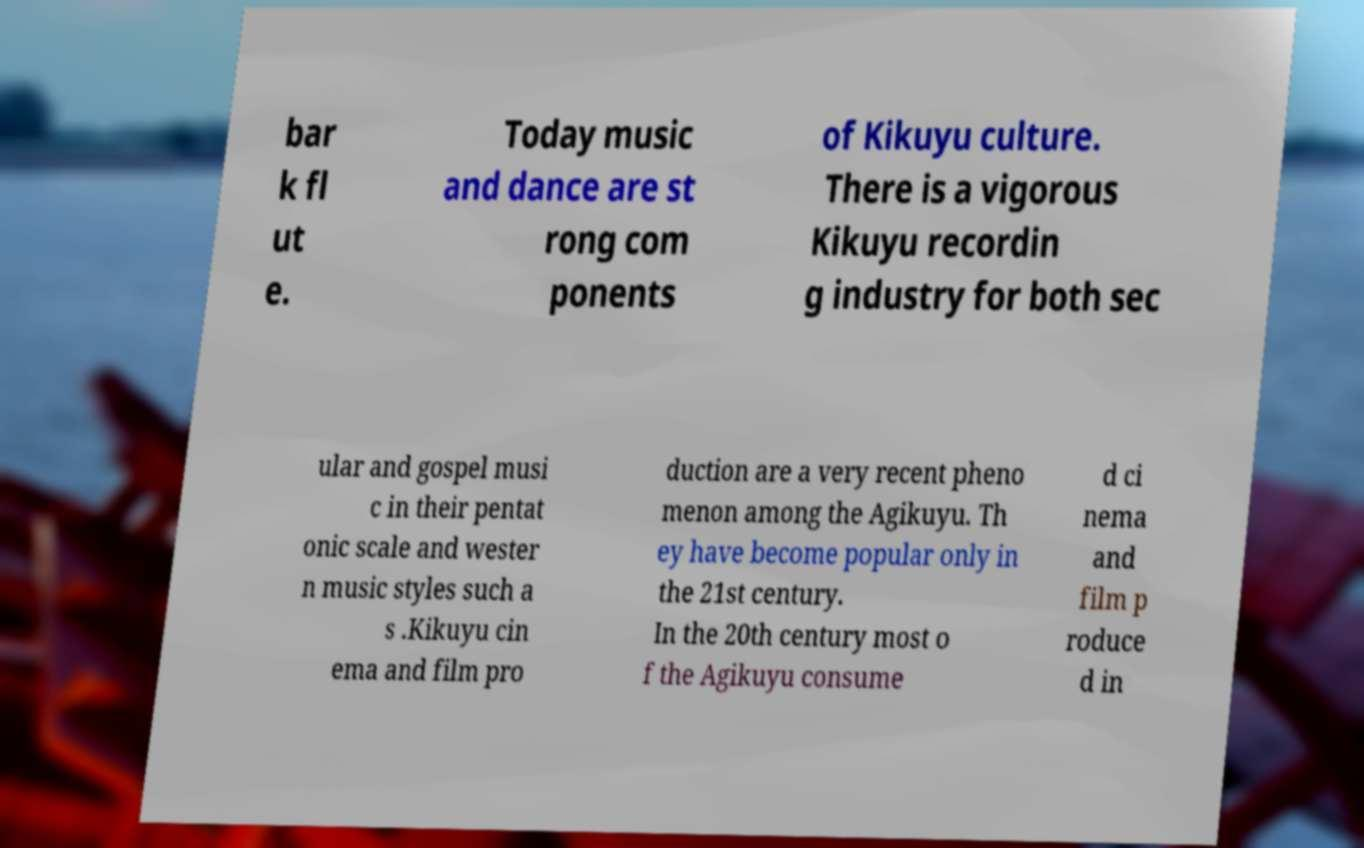Can you read and provide the text displayed in the image?This photo seems to have some interesting text. Can you extract and type it out for me? bar k fl ut e. Today music and dance are st rong com ponents of Kikuyu culture. There is a vigorous Kikuyu recordin g industry for both sec ular and gospel musi c in their pentat onic scale and wester n music styles such a s .Kikuyu cin ema and film pro duction are a very recent pheno menon among the Agikuyu. Th ey have become popular only in the 21st century. In the 20th century most o f the Agikuyu consume d ci nema and film p roduce d in 